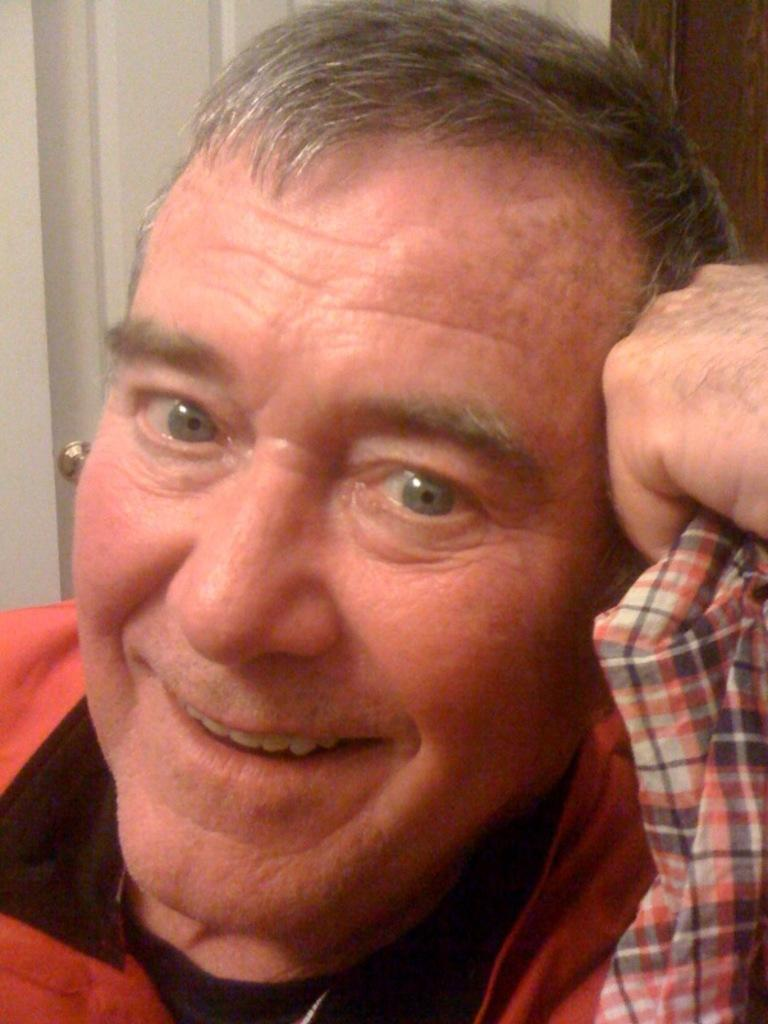Who or what is in the image? There is a person in the image. What can be seen behind the person? There is a white door in the image. Can you describe the door in the image? The door is white. What type of sleet can be seen falling outside the door in the image? There is no sleet visible in the image, and the image does not show any outdoor setting. 